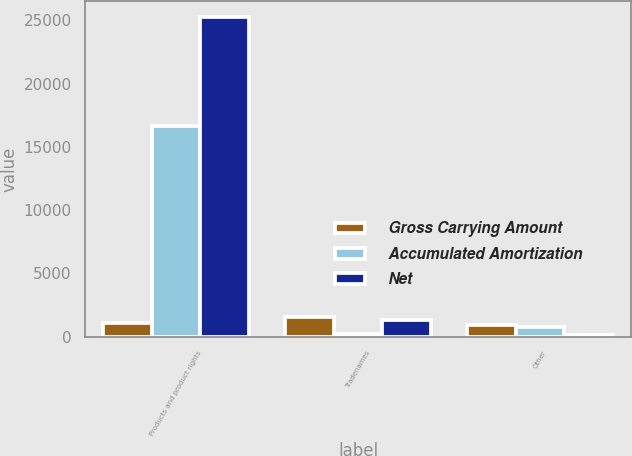<chart> <loc_0><loc_0><loc_500><loc_500><stacked_bar_chart><ecel><fcel>Products and product rights<fcel>Tradenames<fcel>Other<nl><fcel>Gross Carrying Amount<fcel>1090.5<fcel>1521<fcel>896<nl><fcel>Accumulated Amortization<fcel>16678<fcel>236<fcel>745<nl><fcel>Net<fcel>25254<fcel>1285<fcel>151<nl></chart> 